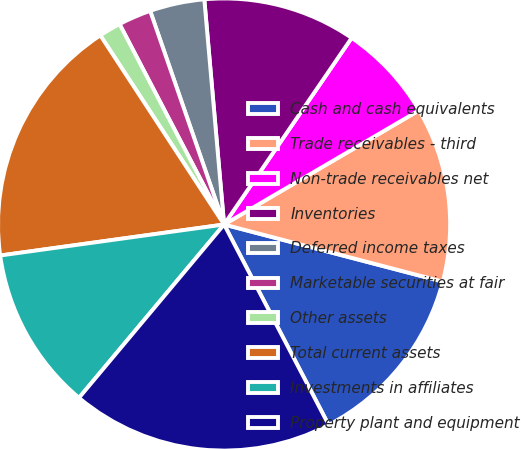<chart> <loc_0><loc_0><loc_500><loc_500><pie_chart><fcel>Cash and cash equivalents<fcel>Trade receivables - third<fcel>Non-trade receivables net<fcel>Inventories<fcel>Deferred income taxes<fcel>Marketable securities at fair<fcel>Other assets<fcel>Total current assets<fcel>Investments in affiliates<fcel>Property plant and equipment<nl><fcel>13.28%<fcel>12.5%<fcel>7.03%<fcel>10.94%<fcel>3.91%<fcel>2.35%<fcel>1.57%<fcel>17.97%<fcel>11.72%<fcel>18.75%<nl></chart> 